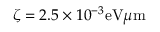Convert formula to latex. <formula><loc_0><loc_0><loc_500><loc_500>\zeta = 2 . 5 \times 1 0 ^ { - 3 } e V \mu m</formula> 